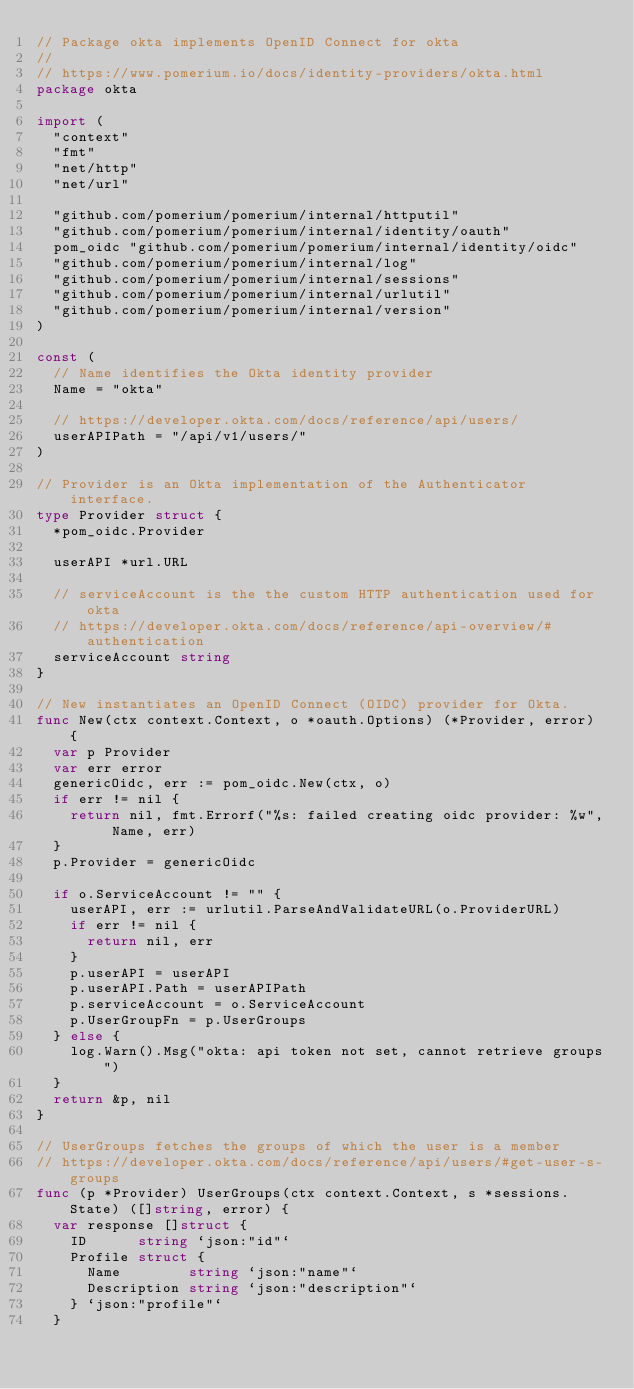Convert code to text. <code><loc_0><loc_0><loc_500><loc_500><_Go_>// Package okta implements OpenID Connect for okta
//
// https://www.pomerium.io/docs/identity-providers/okta.html
package okta

import (
	"context"
	"fmt"
	"net/http"
	"net/url"

	"github.com/pomerium/pomerium/internal/httputil"
	"github.com/pomerium/pomerium/internal/identity/oauth"
	pom_oidc "github.com/pomerium/pomerium/internal/identity/oidc"
	"github.com/pomerium/pomerium/internal/log"
	"github.com/pomerium/pomerium/internal/sessions"
	"github.com/pomerium/pomerium/internal/urlutil"
	"github.com/pomerium/pomerium/internal/version"
)

const (
	// Name identifies the Okta identity provider
	Name = "okta"

	// https://developer.okta.com/docs/reference/api/users/
	userAPIPath = "/api/v1/users/"
)

// Provider is an Okta implementation of the Authenticator interface.
type Provider struct {
	*pom_oidc.Provider

	userAPI *url.URL

	// serviceAccount is the the custom HTTP authentication used for okta
	// https://developer.okta.com/docs/reference/api-overview/#authentication
	serviceAccount string
}

// New instantiates an OpenID Connect (OIDC) provider for Okta.
func New(ctx context.Context, o *oauth.Options) (*Provider, error) {
	var p Provider
	var err error
	genericOidc, err := pom_oidc.New(ctx, o)
	if err != nil {
		return nil, fmt.Errorf("%s: failed creating oidc provider: %w", Name, err)
	}
	p.Provider = genericOidc

	if o.ServiceAccount != "" {
		userAPI, err := urlutil.ParseAndValidateURL(o.ProviderURL)
		if err != nil {
			return nil, err
		}
		p.userAPI = userAPI
		p.userAPI.Path = userAPIPath
		p.serviceAccount = o.ServiceAccount
		p.UserGroupFn = p.UserGroups
	} else {
		log.Warn().Msg("okta: api token not set, cannot retrieve groups")
	}
	return &p, nil
}

// UserGroups fetches the groups of which the user is a member
// https://developer.okta.com/docs/reference/api/users/#get-user-s-groups
func (p *Provider) UserGroups(ctx context.Context, s *sessions.State) ([]string, error) {
	var response []struct {
		ID      string `json:"id"`
		Profile struct {
			Name        string `json:"name"`
			Description string `json:"description"`
		} `json:"profile"`
	}
</code> 